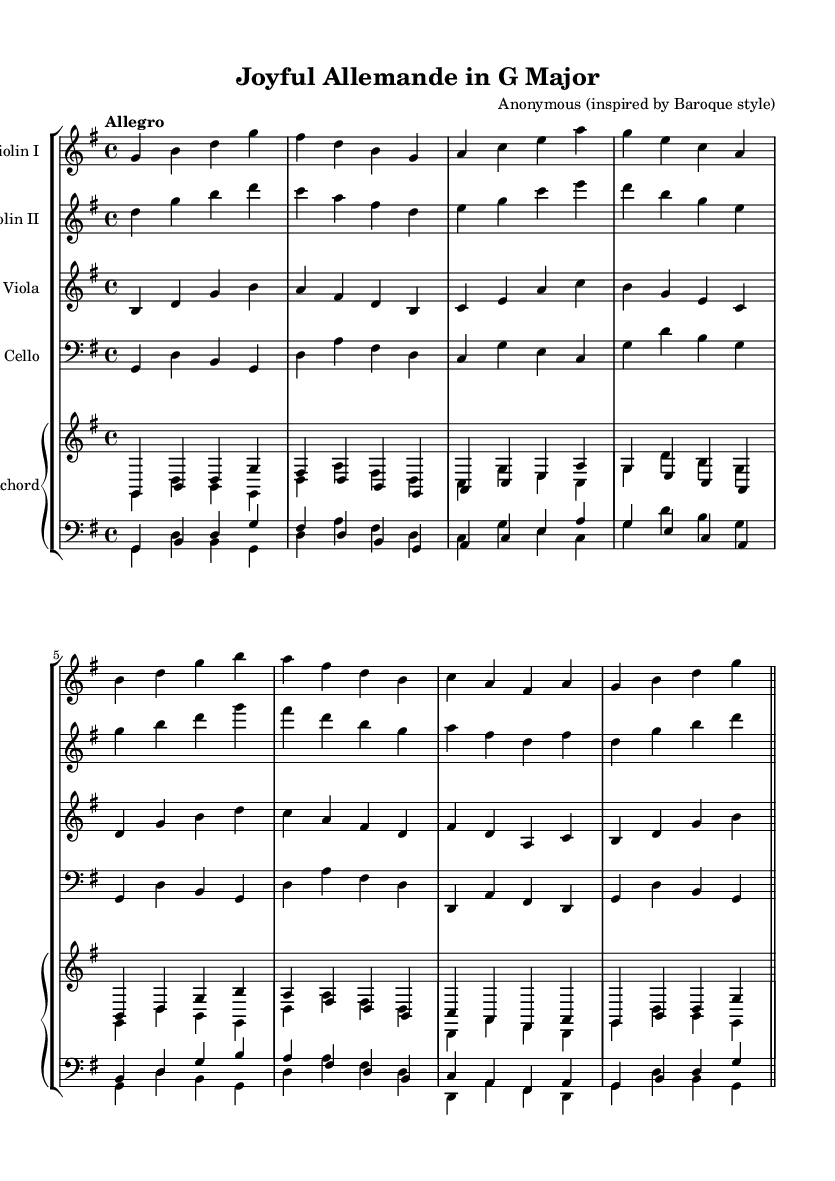What is the key signature of this music? The key signature is indicated at the beginning of the score with one sharp, which designates G major.
Answer: G major What is the time signature of the piece? The time signature is found at the beginning of the score, showing 4 beats in each measure.
Answer: 4/4 What is the tempo marking provided in the music? The tempo marking is specified as "Allegro," indicating a fast and lively pace for the piece.
Answer: Allegro How many instruments are featured in this composition? By counting the distinct instrumental staves in the score, we see there are five instruments: two violins, viola, cello, and harpsichord.
Answer: Five Which dance form is represented by this Baroque piece? The term "Allemande" in the title suggests that this piece is a type of dance common in Baroque suites, characterized by its moderate tempo and flowing style.
Answer: Allemande Do the violins play the same or different melodies? Comparing the two staves for Violin I and Violin II, we find that they play different but complementary melodies, typical of Baroque ensemble writing.
Answer: Different melodies What is the most common rhythmic value used in the score? Observing the notes throughout the score, we can see that quarter notes are the most prevalent rhythmic value.
Answer: Quarter notes 